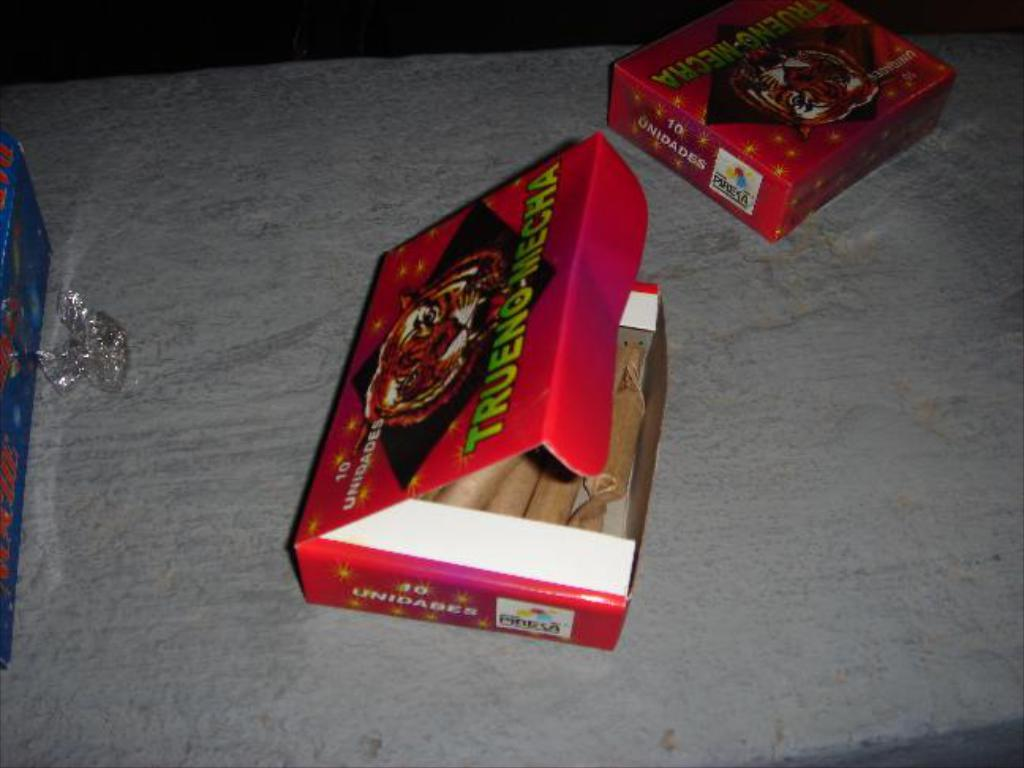What object is present in the image that is typically used for storage or transportation? There is a cardboard box in the image. What can be observed about the food inside the box? The food in the box is cream-colored. On what type of surface are the boxes placed? The boxes are on a gray-colored surface. What type of chickens are visible in the image? There are no chickens present in the image. What type of soda is being served in the image? There is no soda present in the image. 